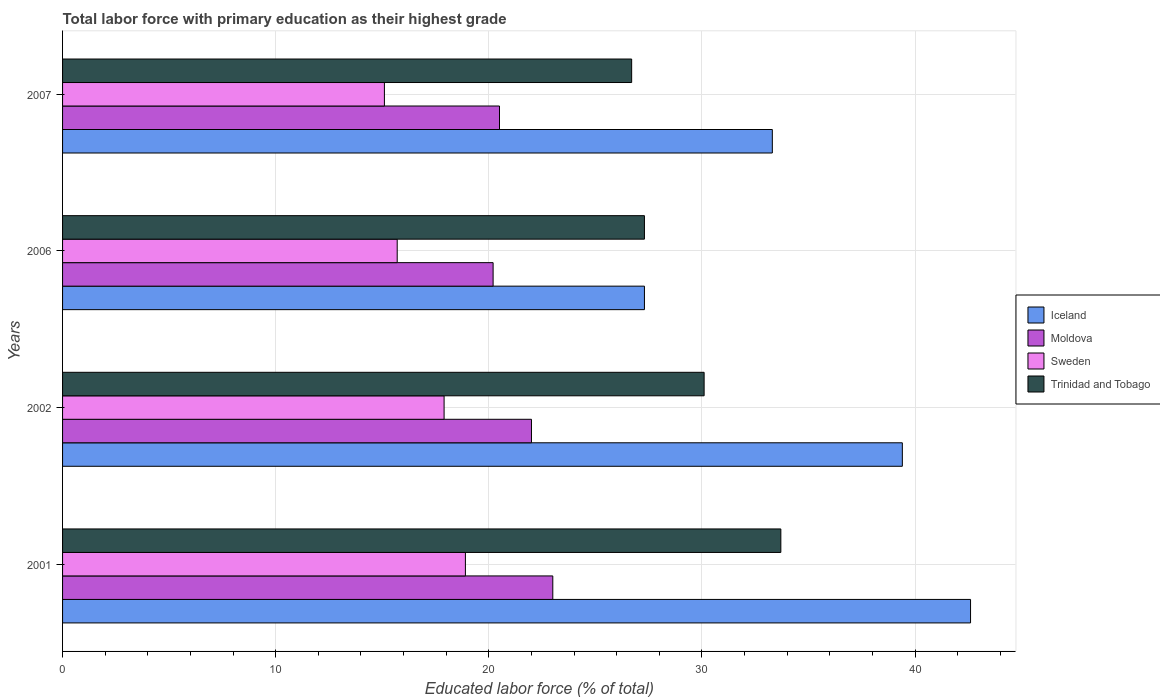Are the number of bars per tick equal to the number of legend labels?
Your answer should be compact. Yes. Are the number of bars on each tick of the Y-axis equal?
Make the answer very short. Yes. How many bars are there on the 4th tick from the top?
Your response must be concise. 4. What is the label of the 1st group of bars from the top?
Give a very brief answer. 2007. What is the percentage of total labor force with primary education in Iceland in 2002?
Ensure brevity in your answer.  39.4. Across all years, what is the minimum percentage of total labor force with primary education in Iceland?
Offer a very short reply. 27.3. In which year was the percentage of total labor force with primary education in Iceland maximum?
Provide a short and direct response. 2001. What is the total percentage of total labor force with primary education in Moldova in the graph?
Provide a short and direct response. 85.7. What is the difference between the percentage of total labor force with primary education in Trinidad and Tobago in 2001 and that in 2007?
Provide a succinct answer. 7. What is the difference between the percentage of total labor force with primary education in Moldova in 2007 and the percentage of total labor force with primary education in Sweden in 2002?
Your answer should be very brief. 2.6. What is the average percentage of total labor force with primary education in Trinidad and Tobago per year?
Provide a succinct answer. 29.45. In the year 2001, what is the difference between the percentage of total labor force with primary education in Trinidad and Tobago and percentage of total labor force with primary education in Moldova?
Provide a succinct answer. 10.7. What is the ratio of the percentage of total labor force with primary education in Trinidad and Tobago in 2001 to that in 2002?
Provide a succinct answer. 1.12. What is the difference between the highest and the second highest percentage of total labor force with primary education in Sweden?
Your response must be concise. 1. What is the difference between the highest and the lowest percentage of total labor force with primary education in Sweden?
Your response must be concise. 3.8. In how many years, is the percentage of total labor force with primary education in Moldova greater than the average percentage of total labor force with primary education in Moldova taken over all years?
Your answer should be very brief. 2. Is the sum of the percentage of total labor force with primary education in Moldova in 2006 and 2007 greater than the maximum percentage of total labor force with primary education in Iceland across all years?
Your response must be concise. No. What does the 3rd bar from the bottom in 2006 represents?
Provide a short and direct response. Sweden. Is it the case that in every year, the sum of the percentage of total labor force with primary education in Moldova and percentage of total labor force with primary education in Trinidad and Tobago is greater than the percentage of total labor force with primary education in Sweden?
Ensure brevity in your answer.  Yes. How many bars are there?
Give a very brief answer. 16. Are all the bars in the graph horizontal?
Offer a terse response. Yes. Are the values on the major ticks of X-axis written in scientific E-notation?
Give a very brief answer. No. How are the legend labels stacked?
Keep it short and to the point. Vertical. What is the title of the graph?
Give a very brief answer. Total labor force with primary education as their highest grade. Does "Sri Lanka" appear as one of the legend labels in the graph?
Keep it short and to the point. No. What is the label or title of the X-axis?
Give a very brief answer. Educated labor force (% of total). What is the Educated labor force (% of total) in Iceland in 2001?
Give a very brief answer. 42.6. What is the Educated labor force (% of total) in Sweden in 2001?
Provide a succinct answer. 18.9. What is the Educated labor force (% of total) in Trinidad and Tobago in 2001?
Make the answer very short. 33.7. What is the Educated labor force (% of total) in Iceland in 2002?
Provide a short and direct response. 39.4. What is the Educated labor force (% of total) of Sweden in 2002?
Offer a terse response. 17.9. What is the Educated labor force (% of total) of Trinidad and Tobago in 2002?
Provide a succinct answer. 30.1. What is the Educated labor force (% of total) in Iceland in 2006?
Provide a short and direct response. 27.3. What is the Educated labor force (% of total) in Moldova in 2006?
Your response must be concise. 20.2. What is the Educated labor force (% of total) in Sweden in 2006?
Provide a short and direct response. 15.7. What is the Educated labor force (% of total) of Trinidad and Tobago in 2006?
Ensure brevity in your answer.  27.3. What is the Educated labor force (% of total) of Iceland in 2007?
Your answer should be very brief. 33.3. What is the Educated labor force (% of total) in Moldova in 2007?
Ensure brevity in your answer.  20.5. What is the Educated labor force (% of total) of Sweden in 2007?
Offer a terse response. 15.1. What is the Educated labor force (% of total) of Trinidad and Tobago in 2007?
Offer a terse response. 26.7. Across all years, what is the maximum Educated labor force (% of total) in Iceland?
Make the answer very short. 42.6. Across all years, what is the maximum Educated labor force (% of total) of Moldova?
Your answer should be compact. 23. Across all years, what is the maximum Educated labor force (% of total) of Sweden?
Your response must be concise. 18.9. Across all years, what is the maximum Educated labor force (% of total) in Trinidad and Tobago?
Make the answer very short. 33.7. Across all years, what is the minimum Educated labor force (% of total) of Iceland?
Make the answer very short. 27.3. Across all years, what is the minimum Educated labor force (% of total) in Moldova?
Your response must be concise. 20.2. Across all years, what is the minimum Educated labor force (% of total) in Sweden?
Provide a succinct answer. 15.1. Across all years, what is the minimum Educated labor force (% of total) in Trinidad and Tobago?
Your response must be concise. 26.7. What is the total Educated labor force (% of total) of Iceland in the graph?
Ensure brevity in your answer.  142.6. What is the total Educated labor force (% of total) of Moldova in the graph?
Your answer should be very brief. 85.7. What is the total Educated labor force (% of total) in Sweden in the graph?
Keep it short and to the point. 67.6. What is the total Educated labor force (% of total) in Trinidad and Tobago in the graph?
Your answer should be compact. 117.8. What is the difference between the Educated labor force (% of total) of Iceland in 2001 and that in 2002?
Give a very brief answer. 3.2. What is the difference between the Educated labor force (% of total) of Trinidad and Tobago in 2001 and that in 2002?
Provide a succinct answer. 3.6. What is the difference between the Educated labor force (% of total) in Iceland in 2001 and that in 2006?
Give a very brief answer. 15.3. What is the difference between the Educated labor force (% of total) of Moldova in 2001 and that in 2006?
Provide a short and direct response. 2.8. What is the difference between the Educated labor force (% of total) in Sweden in 2001 and that in 2006?
Provide a succinct answer. 3.2. What is the difference between the Educated labor force (% of total) of Sweden in 2001 and that in 2007?
Offer a very short reply. 3.8. What is the difference between the Educated labor force (% of total) of Trinidad and Tobago in 2001 and that in 2007?
Provide a short and direct response. 7. What is the difference between the Educated labor force (% of total) of Iceland in 2002 and that in 2006?
Offer a terse response. 12.1. What is the difference between the Educated labor force (% of total) of Trinidad and Tobago in 2002 and that in 2006?
Keep it short and to the point. 2.8. What is the difference between the Educated labor force (% of total) in Iceland in 2002 and that in 2007?
Offer a terse response. 6.1. What is the difference between the Educated labor force (% of total) of Sweden in 2002 and that in 2007?
Provide a short and direct response. 2.8. What is the difference between the Educated labor force (% of total) of Iceland in 2006 and that in 2007?
Give a very brief answer. -6. What is the difference between the Educated labor force (% of total) of Iceland in 2001 and the Educated labor force (% of total) of Moldova in 2002?
Give a very brief answer. 20.6. What is the difference between the Educated labor force (% of total) in Iceland in 2001 and the Educated labor force (% of total) in Sweden in 2002?
Offer a very short reply. 24.7. What is the difference between the Educated labor force (% of total) in Moldova in 2001 and the Educated labor force (% of total) in Trinidad and Tobago in 2002?
Your response must be concise. -7.1. What is the difference between the Educated labor force (% of total) of Sweden in 2001 and the Educated labor force (% of total) of Trinidad and Tobago in 2002?
Offer a terse response. -11.2. What is the difference between the Educated labor force (% of total) in Iceland in 2001 and the Educated labor force (% of total) in Moldova in 2006?
Your response must be concise. 22.4. What is the difference between the Educated labor force (% of total) of Iceland in 2001 and the Educated labor force (% of total) of Sweden in 2006?
Provide a short and direct response. 26.9. What is the difference between the Educated labor force (% of total) in Moldova in 2001 and the Educated labor force (% of total) in Trinidad and Tobago in 2006?
Your answer should be very brief. -4.3. What is the difference between the Educated labor force (% of total) of Iceland in 2001 and the Educated labor force (% of total) of Moldova in 2007?
Your answer should be very brief. 22.1. What is the difference between the Educated labor force (% of total) of Iceland in 2001 and the Educated labor force (% of total) of Trinidad and Tobago in 2007?
Your answer should be very brief. 15.9. What is the difference between the Educated labor force (% of total) of Moldova in 2001 and the Educated labor force (% of total) of Sweden in 2007?
Your answer should be very brief. 7.9. What is the difference between the Educated labor force (% of total) of Iceland in 2002 and the Educated labor force (% of total) of Sweden in 2006?
Offer a terse response. 23.7. What is the difference between the Educated labor force (% of total) of Iceland in 2002 and the Educated labor force (% of total) of Trinidad and Tobago in 2006?
Keep it short and to the point. 12.1. What is the difference between the Educated labor force (% of total) of Moldova in 2002 and the Educated labor force (% of total) of Sweden in 2006?
Give a very brief answer. 6.3. What is the difference between the Educated labor force (% of total) of Iceland in 2002 and the Educated labor force (% of total) of Moldova in 2007?
Make the answer very short. 18.9. What is the difference between the Educated labor force (% of total) in Iceland in 2002 and the Educated labor force (% of total) in Sweden in 2007?
Offer a very short reply. 24.3. What is the difference between the Educated labor force (% of total) in Moldova in 2002 and the Educated labor force (% of total) in Trinidad and Tobago in 2007?
Give a very brief answer. -4.7. What is the difference between the Educated labor force (% of total) of Iceland in 2006 and the Educated labor force (% of total) of Moldova in 2007?
Make the answer very short. 6.8. What is the difference between the Educated labor force (% of total) of Iceland in 2006 and the Educated labor force (% of total) of Trinidad and Tobago in 2007?
Make the answer very short. 0.6. What is the difference between the Educated labor force (% of total) of Moldova in 2006 and the Educated labor force (% of total) of Trinidad and Tobago in 2007?
Make the answer very short. -6.5. What is the difference between the Educated labor force (% of total) in Sweden in 2006 and the Educated labor force (% of total) in Trinidad and Tobago in 2007?
Keep it short and to the point. -11. What is the average Educated labor force (% of total) in Iceland per year?
Offer a very short reply. 35.65. What is the average Educated labor force (% of total) of Moldova per year?
Provide a short and direct response. 21.43. What is the average Educated labor force (% of total) in Sweden per year?
Provide a short and direct response. 16.9. What is the average Educated labor force (% of total) in Trinidad and Tobago per year?
Give a very brief answer. 29.45. In the year 2001, what is the difference between the Educated labor force (% of total) in Iceland and Educated labor force (% of total) in Moldova?
Ensure brevity in your answer.  19.6. In the year 2001, what is the difference between the Educated labor force (% of total) in Iceland and Educated labor force (% of total) in Sweden?
Your answer should be compact. 23.7. In the year 2001, what is the difference between the Educated labor force (% of total) in Iceland and Educated labor force (% of total) in Trinidad and Tobago?
Provide a short and direct response. 8.9. In the year 2001, what is the difference between the Educated labor force (% of total) of Moldova and Educated labor force (% of total) of Sweden?
Make the answer very short. 4.1. In the year 2001, what is the difference between the Educated labor force (% of total) in Moldova and Educated labor force (% of total) in Trinidad and Tobago?
Offer a terse response. -10.7. In the year 2001, what is the difference between the Educated labor force (% of total) of Sweden and Educated labor force (% of total) of Trinidad and Tobago?
Your answer should be very brief. -14.8. In the year 2002, what is the difference between the Educated labor force (% of total) in Iceland and Educated labor force (% of total) in Moldova?
Provide a short and direct response. 17.4. In the year 2002, what is the difference between the Educated labor force (% of total) in Iceland and Educated labor force (% of total) in Sweden?
Your response must be concise. 21.5. In the year 2002, what is the difference between the Educated labor force (% of total) of Iceland and Educated labor force (% of total) of Trinidad and Tobago?
Provide a short and direct response. 9.3. In the year 2002, what is the difference between the Educated labor force (% of total) in Moldova and Educated labor force (% of total) in Sweden?
Offer a very short reply. 4.1. In the year 2002, what is the difference between the Educated labor force (% of total) of Moldova and Educated labor force (% of total) of Trinidad and Tobago?
Provide a short and direct response. -8.1. In the year 2006, what is the difference between the Educated labor force (% of total) in Iceland and Educated labor force (% of total) in Sweden?
Provide a short and direct response. 11.6. In the year 2006, what is the difference between the Educated labor force (% of total) of Moldova and Educated labor force (% of total) of Sweden?
Offer a terse response. 4.5. In the year 2007, what is the difference between the Educated labor force (% of total) in Iceland and Educated labor force (% of total) in Sweden?
Offer a very short reply. 18.2. In the year 2007, what is the difference between the Educated labor force (% of total) of Moldova and Educated labor force (% of total) of Sweden?
Ensure brevity in your answer.  5.4. What is the ratio of the Educated labor force (% of total) in Iceland in 2001 to that in 2002?
Ensure brevity in your answer.  1.08. What is the ratio of the Educated labor force (% of total) in Moldova in 2001 to that in 2002?
Provide a short and direct response. 1.05. What is the ratio of the Educated labor force (% of total) in Sweden in 2001 to that in 2002?
Provide a succinct answer. 1.06. What is the ratio of the Educated labor force (% of total) in Trinidad and Tobago in 2001 to that in 2002?
Your response must be concise. 1.12. What is the ratio of the Educated labor force (% of total) in Iceland in 2001 to that in 2006?
Your answer should be very brief. 1.56. What is the ratio of the Educated labor force (% of total) in Moldova in 2001 to that in 2006?
Your response must be concise. 1.14. What is the ratio of the Educated labor force (% of total) in Sweden in 2001 to that in 2006?
Your answer should be compact. 1.2. What is the ratio of the Educated labor force (% of total) in Trinidad and Tobago in 2001 to that in 2006?
Your response must be concise. 1.23. What is the ratio of the Educated labor force (% of total) in Iceland in 2001 to that in 2007?
Your response must be concise. 1.28. What is the ratio of the Educated labor force (% of total) of Moldova in 2001 to that in 2007?
Ensure brevity in your answer.  1.12. What is the ratio of the Educated labor force (% of total) of Sweden in 2001 to that in 2007?
Make the answer very short. 1.25. What is the ratio of the Educated labor force (% of total) in Trinidad and Tobago in 2001 to that in 2007?
Keep it short and to the point. 1.26. What is the ratio of the Educated labor force (% of total) in Iceland in 2002 to that in 2006?
Offer a terse response. 1.44. What is the ratio of the Educated labor force (% of total) in Moldova in 2002 to that in 2006?
Make the answer very short. 1.09. What is the ratio of the Educated labor force (% of total) in Sweden in 2002 to that in 2006?
Make the answer very short. 1.14. What is the ratio of the Educated labor force (% of total) in Trinidad and Tobago in 2002 to that in 2006?
Provide a short and direct response. 1.1. What is the ratio of the Educated labor force (% of total) in Iceland in 2002 to that in 2007?
Give a very brief answer. 1.18. What is the ratio of the Educated labor force (% of total) in Moldova in 2002 to that in 2007?
Keep it short and to the point. 1.07. What is the ratio of the Educated labor force (% of total) of Sweden in 2002 to that in 2007?
Offer a terse response. 1.19. What is the ratio of the Educated labor force (% of total) in Trinidad and Tobago in 2002 to that in 2007?
Give a very brief answer. 1.13. What is the ratio of the Educated labor force (% of total) in Iceland in 2006 to that in 2007?
Keep it short and to the point. 0.82. What is the ratio of the Educated labor force (% of total) of Moldova in 2006 to that in 2007?
Make the answer very short. 0.99. What is the ratio of the Educated labor force (% of total) of Sweden in 2006 to that in 2007?
Offer a terse response. 1.04. What is the ratio of the Educated labor force (% of total) in Trinidad and Tobago in 2006 to that in 2007?
Offer a terse response. 1.02. What is the difference between the highest and the second highest Educated labor force (% of total) in Sweden?
Give a very brief answer. 1. What is the difference between the highest and the second highest Educated labor force (% of total) of Trinidad and Tobago?
Your answer should be very brief. 3.6. What is the difference between the highest and the lowest Educated labor force (% of total) of Moldova?
Make the answer very short. 2.8. What is the difference between the highest and the lowest Educated labor force (% of total) in Trinidad and Tobago?
Make the answer very short. 7. 